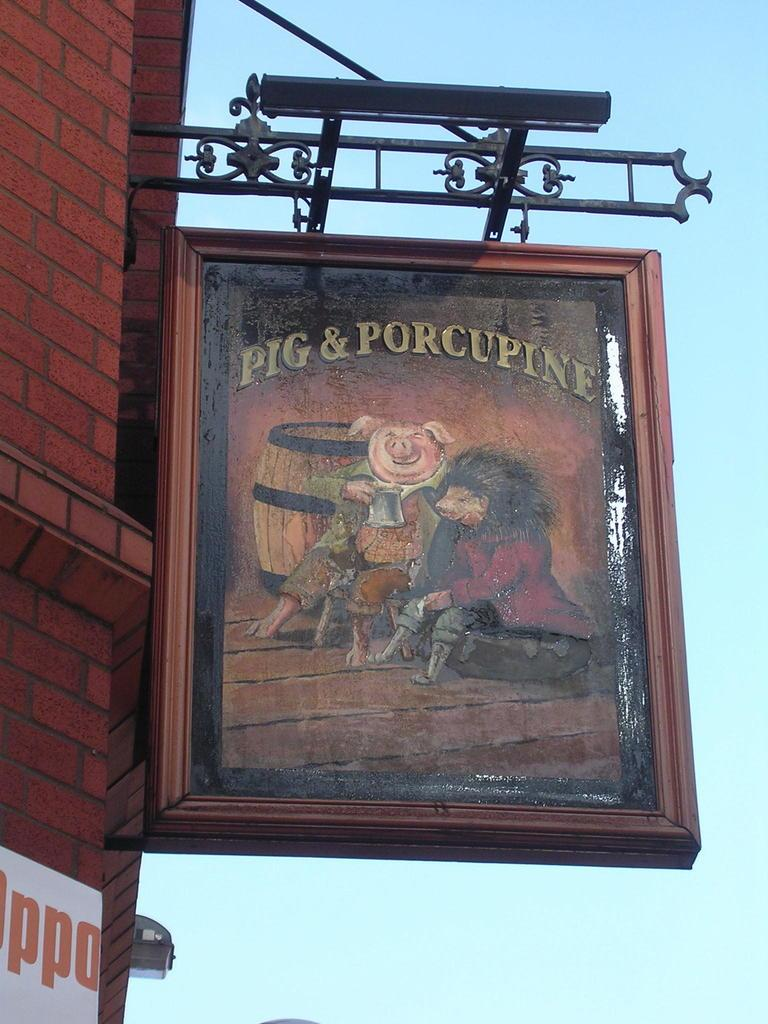<image>
Summarize the visual content of the image. Sign outside of a building that says "Pig & Porcupine". 